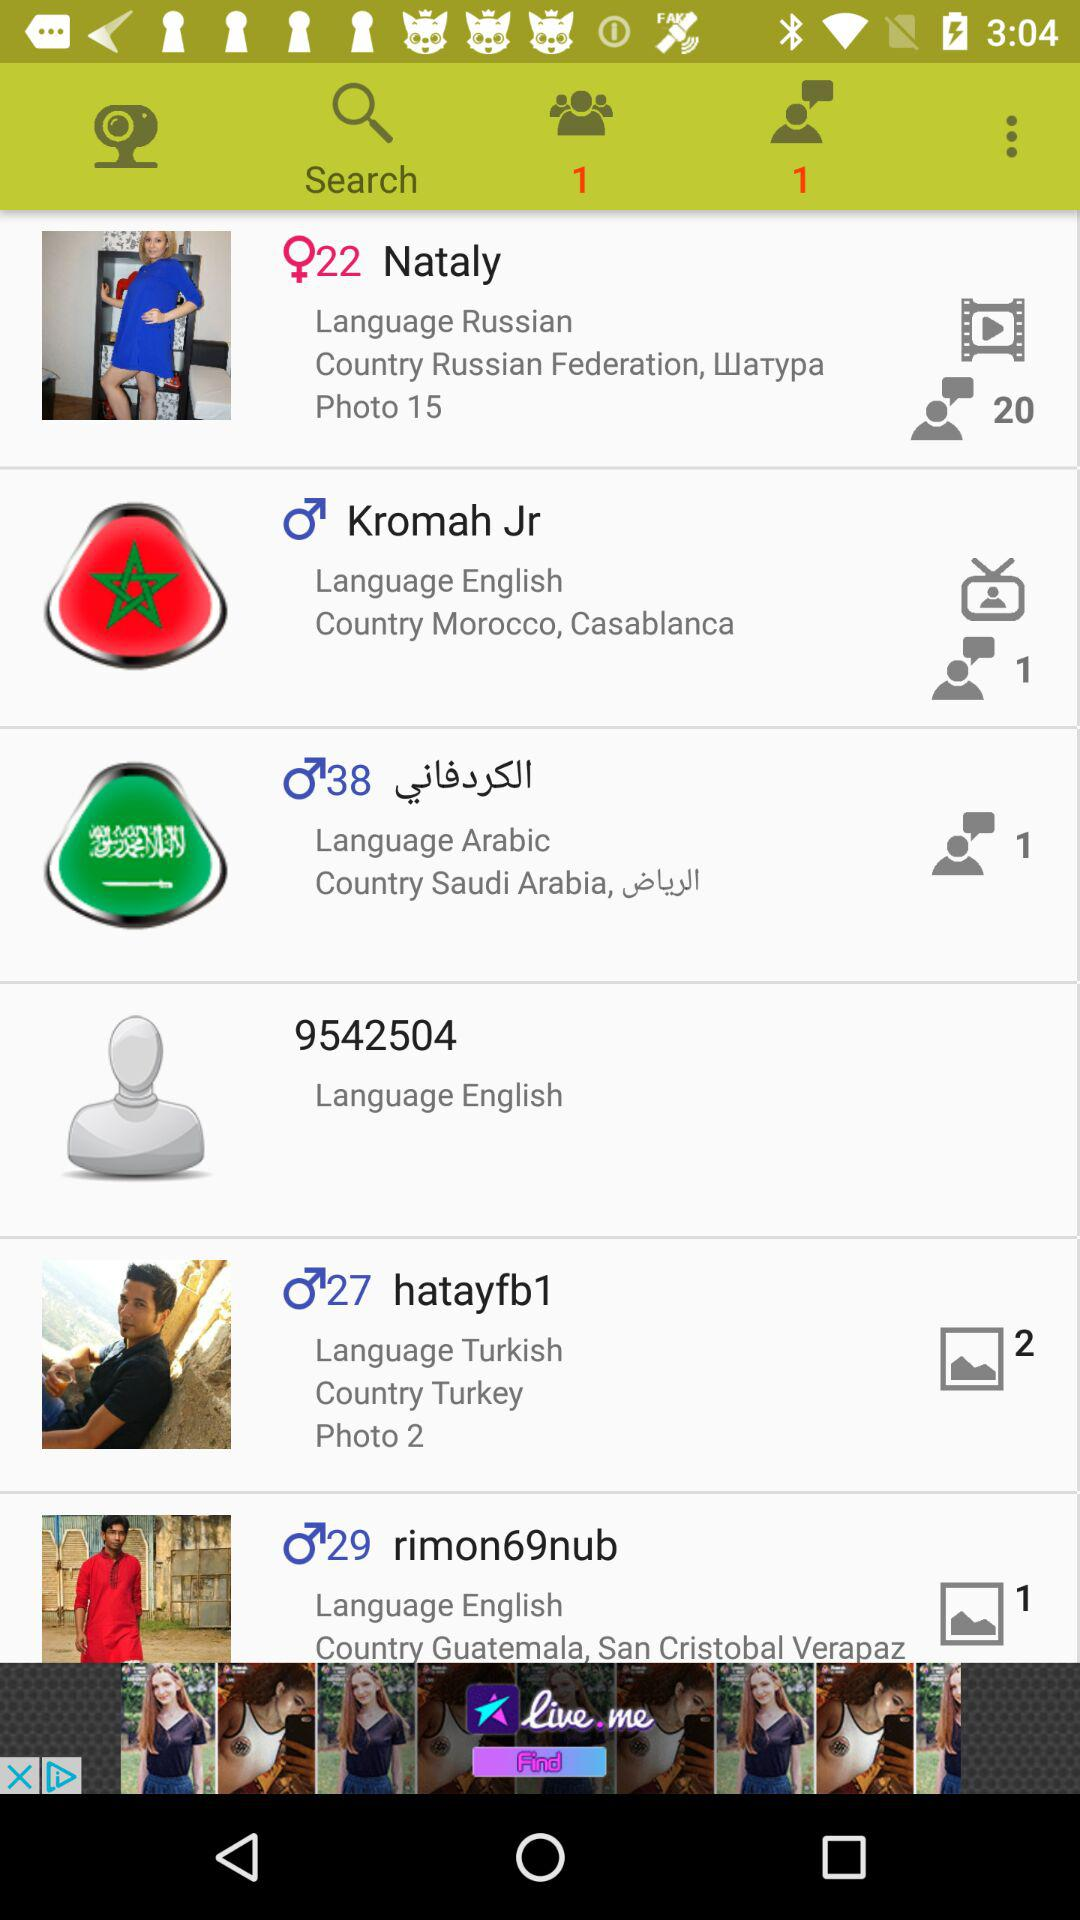Which language does Nataly use? Nataly uses the Russian language. 